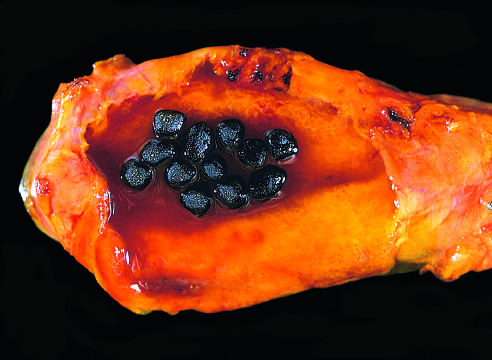re a few residual cardiac muscle cells present in this otherwise unremarkable gallbladder from a patient with a mechanical mitral valve prosthesis, leading to chronic intravascular hemolysis?
Answer the question using a single word or phrase. No 